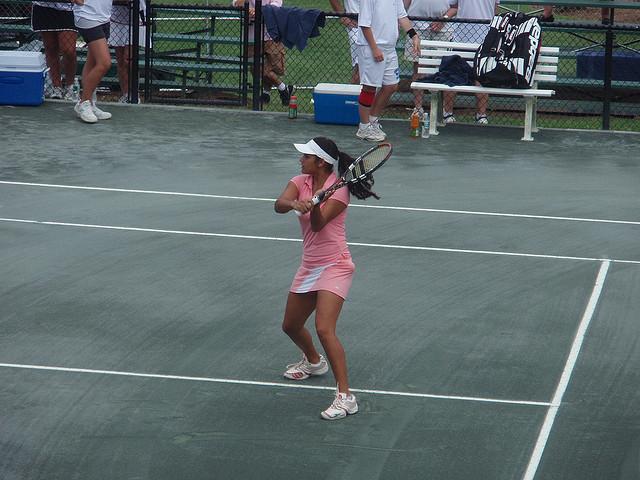What is on the white bench?
Concise answer only. Bags. Is she about to hit the ball?
Short answer required. Yes. What is she about to hit?
Give a very brief answer. Tennis ball. 